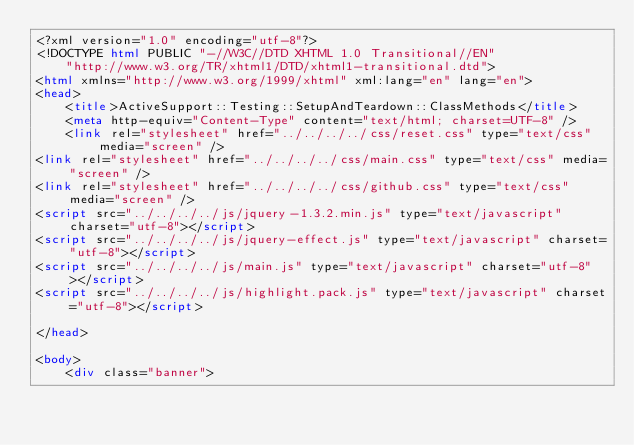<code> <loc_0><loc_0><loc_500><loc_500><_HTML_><?xml version="1.0" encoding="utf-8"?>
<!DOCTYPE html PUBLIC "-//W3C//DTD XHTML 1.0 Transitional//EN"
    "http://www.w3.org/TR/xhtml1/DTD/xhtml1-transitional.dtd">
<html xmlns="http://www.w3.org/1999/xhtml" xml:lang="en" lang="en">
<head>
    <title>ActiveSupport::Testing::SetupAndTeardown::ClassMethods</title>
    <meta http-equiv="Content-Type" content="text/html; charset=UTF-8" />
    <link rel="stylesheet" href="../../../../css/reset.css" type="text/css" media="screen" />
<link rel="stylesheet" href="../../../../css/main.css" type="text/css" media="screen" />
<link rel="stylesheet" href="../../../../css/github.css" type="text/css" media="screen" />
<script src="../../../../js/jquery-1.3.2.min.js" type="text/javascript" charset="utf-8"></script>
<script src="../../../../js/jquery-effect.js" type="text/javascript" charset="utf-8"></script>
<script src="../../../../js/main.js" type="text/javascript" charset="utf-8"></script>
<script src="../../../../js/highlight.pack.js" type="text/javascript" charset="utf-8"></script>

</head>

<body>     
    <div class="banner">
        </code> 